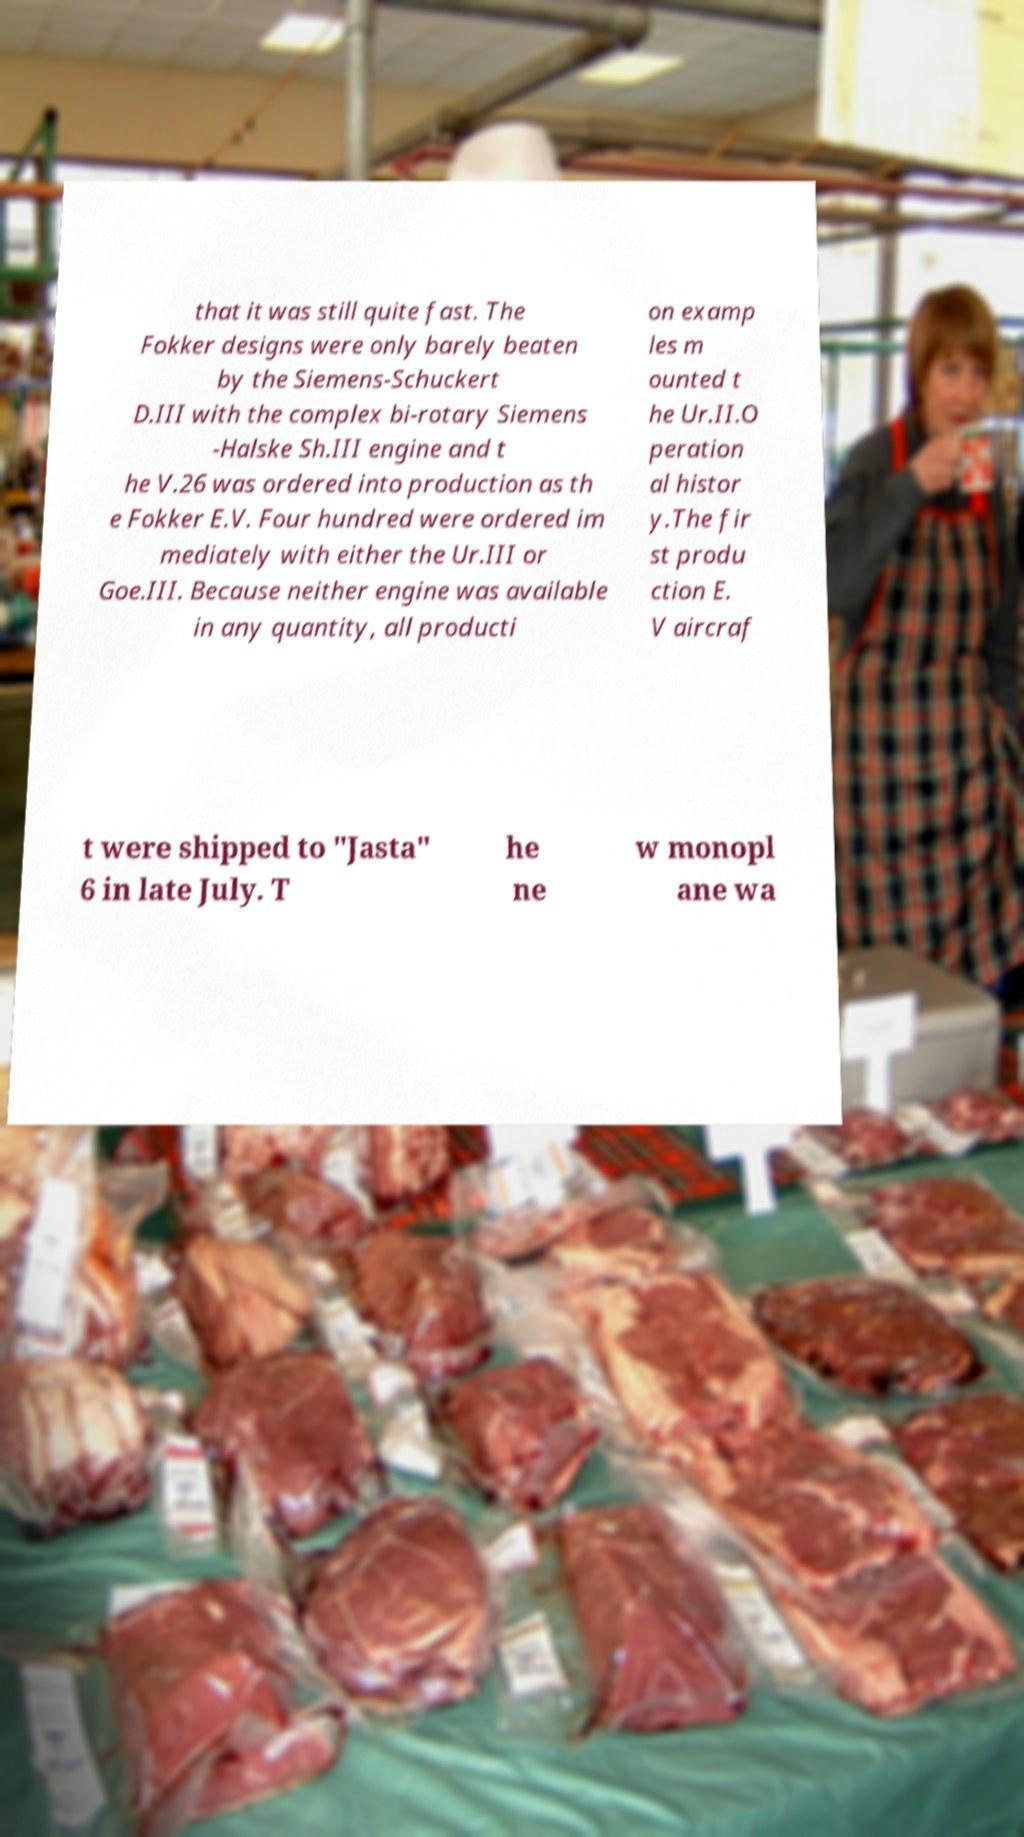Could you assist in decoding the text presented in this image and type it out clearly? that it was still quite fast. The Fokker designs were only barely beaten by the Siemens-Schuckert D.III with the complex bi-rotary Siemens -Halske Sh.III engine and t he V.26 was ordered into production as th e Fokker E.V. Four hundred were ordered im mediately with either the Ur.III or Goe.III. Because neither engine was available in any quantity, all producti on examp les m ounted t he Ur.II.O peration al histor y.The fir st produ ction E. V aircraf t were shipped to "Jasta" 6 in late July. T he ne w monopl ane wa 